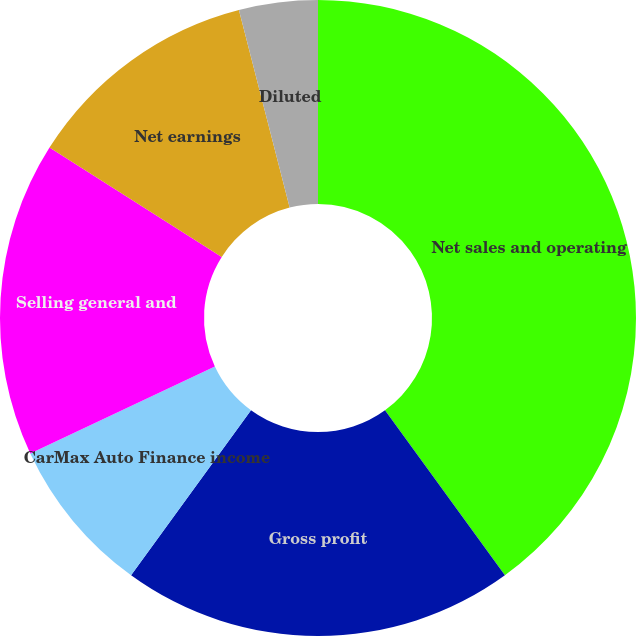Convert chart. <chart><loc_0><loc_0><loc_500><loc_500><pie_chart><fcel>Net sales and operating<fcel>Gross profit<fcel>CarMax Auto Finance income<fcel>Selling general and<fcel>Net earnings<fcel>Basic<fcel>Diluted<nl><fcel>40.0%<fcel>20.0%<fcel>8.0%<fcel>16.0%<fcel>12.0%<fcel>0.0%<fcel>4.0%<nl></chart> 